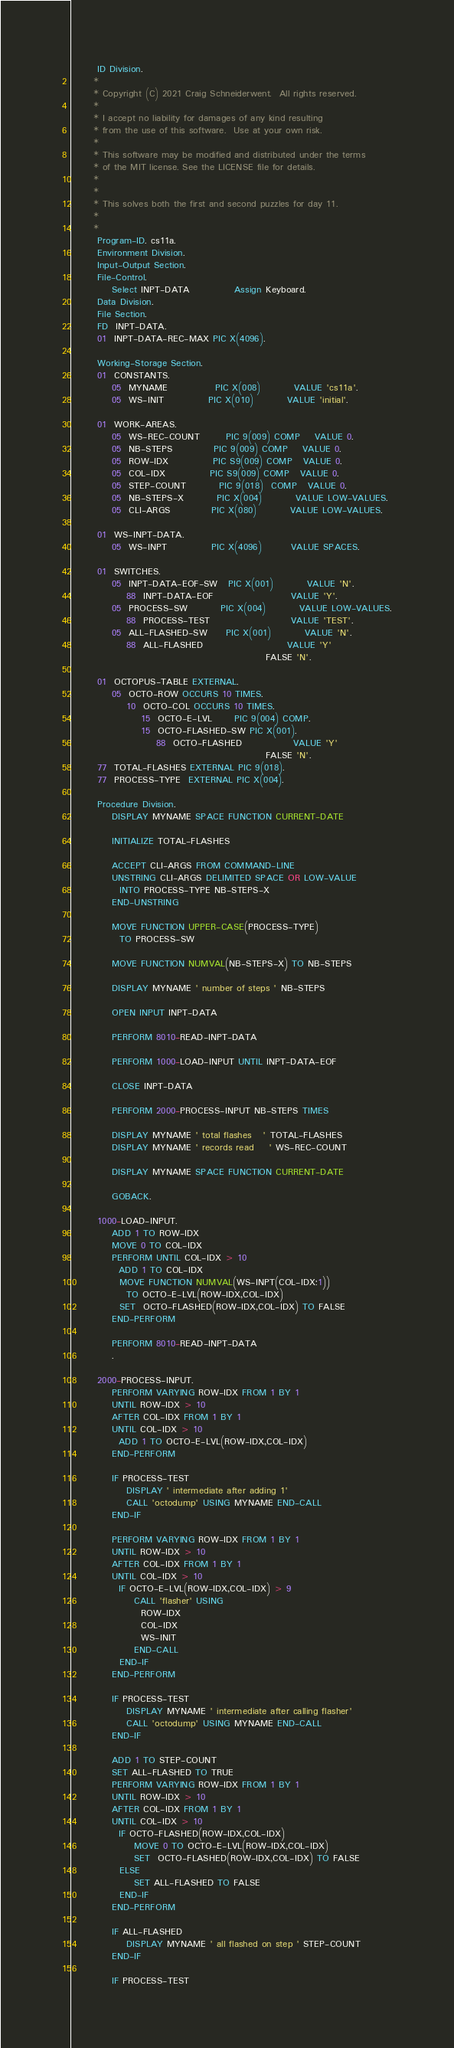<code> <loc_0><loc_0><loc_500><loc_500><_COBOL_>       ID Division.
      * 
      * Copyright (C) 2021 Craig Schneiderwent.  All rights reserved.
      * 
      * I accept no liability for damages of any kind resulting 
      * from the use of this software.  Use at your own risk.
      *
      * This software may be modified and distributed under the terms
      * of the MIT license. See the LICENSE file for details.
      *
      * 
      * This solves both the first and second puzzles for day 11. 
      * 
      * 
       Program-ID. cs11a.
       Environment Division.
       Input-Output Section.
       File-Control.
           Select INPT-DATA            Assign Keyboard.
       Data Division.
       File Section.
       FD  INPT-DATA.
       01  INPT-DATA-REC-MAX PIC X(4096).

       Working-Storage Section.
       01  CONSTANTS.
           05  MYNAME             PIC X(008)         VALUE 'cs11a'.
           05  WS-INIT            PIC X(010)         VALUE 'initial'.

       01  WORK-AREAS.
           05  WS-REC-COUNT       PIC 9(009) COMP    VALUE 0.
           05  NB-STEPS           PIC 9(009) COMP    VALUE 0.
           05  ROW-IDX            PIC S9(009) COMP   VALUE 0.
           05  COL-IDX            PIC S9(009) COMP   VALUE 0.
           05  STEP-COUNT         PIC 9(018)  COMP   VALUE 0.
           05  NB-STEPS-X         PIC X(004)         VALUE LOW-VALUES.
           05  CLI-ARGS           PIC X(080)         VALUE LOW-VALUES.

       01  WS-INPT-DATA.
           05  WS-INPT            PIC X(4096)        VALUE SPACES.

       01  SWITCHES.
           05  INPT-DATA-EOF-SW   PIC X(001)         VALUE 'N'.
               88  INPT-DATA-EOF                     VALUE 'Y'.
           05  PROCESS-SW         PIC X(004)         VALUE LOW-VALUES.
               88  PROCESS-TEST                      VALUE 'TEST'.
           05  ALL-FLASHED-SW     PIC X(001)         VALUE 'N'.
               88  ALL-FLASHED                       VALUE 'Y'
                                                     FALSE 'N'.

       01  OCTOPUS-TABLE EXTERNAL.
           05  OCTO-ROW OCCURS 10 TIMES.
               10  OCTO-COL OCCURS 10 TIMES.
                   15  OCTO-E-LVL      PIC 9(004) COMP.
                   15  OCTO-FLASHED-SW PIC X(001).
                       88  OCTO-FLASHED              VALUE 'Y'
                                                     FALSE 'N'.
       77  TOTAL-FLASHES EXTERNAL PIC 9(018).
       77  PROCESS-TYPE  EXTERNAL PIC X(004).

       Procedure Division.
           DISPLAY MYNAME SPACE FUNCTION CURRENT-DATE

           INITIALIZE TOTAL-FLASHES

           ACCEPT CLI-ARGS FROM COMMAND-LINE
           UNSTRING CLI-ARGS DELIMITED SPACE OR LOW-VALUE
             INTO PROCESS-TYPE NB-STEPS-X
           END-UNSTRING

           MOVE FUNCTION UPPER-CASE(PROCESS-TYPE)
             TO PROCESS-SW

           MOVE FUNCTION NUMVAL(NB-STEPS-X) TO NB-STEPS

           DISPLAY MYNAME ' number of steps ' NB-STEPS

           OPEN INPUT INPT-DATA

           PERFORM 8010-READ-INPT-DATA

           PERFORM 1000-LOAD-INPUT UNTIL INPT-DATA-EOF

           CLOSE INPT-DATA

           PERFORM 2000-PROCESS-INPUT NB-STEPS TIMES

           DISPLAY MYNAME ' total flashes   ' TOTAL-FLASHES
           DISPLAY MYNAME ' records read    ' WS-REC-COUNT

           DISPLAY MYNAME SPACE FUNCTION CURRENT-DATE

           GOBACK.

       1000-LOAD-INPUT.
           ADD 1 TO ROW-IDX
           MOVE 0 TO COL-IDX
           PERFORM UNTIL COL-IDX > 10
             ADD 1 TO COL-IDX
             MOVE FUNCTION NUMVAL(WS-INPT(COL-IDX:1))
               TO OCTO-E-LVL(ROW-IDX,COL-IDX)
             SET  OCTO-FLASHED(ROW-IDX,COL-IDX) TO FALSE
           END-PERFORM

           PERFORM 8010-READ-INPT-DATA
           .

       2000-PROCESS-INPUT.
           PERFORM VARYING ROW-IDX FROM 1 BY 1
           UNTIL ROW-IDX > 10
           AFTER COL-IDX FROM 1 BY 1
           UNTIL COL-IDX > 10
             ADD 1 TO OCTO-E-LVL(ROW-IDX,COL-IDX)
           END-PERFORM

           IF PROCESS-TEST
               DISPLAY ' intermediate after adding 1'
               CALL 'octodump' USING MYNAME END-CALL
           END-IF

           PERFORM VARYING ROW-IDX FROM 1 BY 1
           UNTIL ROW-IDX > 10
           AFTER COL-IDX FROM 1 BY 1
           UNTIL COL-IDX > 10
             IF OCTO-E-LVL(ROW-IDX,COL-IDX) > 9
                 CALL 'flasher' USING
                   ROW-IDX
                   COL-IDX
                   WS-INIT
                 END-CALL
             END-IF
           END-PERFORM

           IF PROCESS-TEST
               DISPLAY MYNAME ' intermediate after calling flasher'
               CALL 'octodump' USING MYNAME END-CALL
           END-IF

           ADD 1 TO STEP-COUNT
           SET ALL-FLASHED TO TRUE
           PERFORM VARYING ROW-IDX FROM 1 BY 1
           UNTIL ROW-IDX > 10
           AFTER COL-IDX FROM 1 BY 1
           UNTIL COL-IDX > 10
             IF OCTO-FLASHED(ROW-IDX,COL-IDX)
                 MOVE 0 TO OCTO-E-LVL(ROW-IDX,COL-IDX)
                 SET  OCTO-FLASHED(ROW-IDX,COL-IDX) TO FALSE
             ELSE
                 SET ALL-FLASHED TO FALSE
             END-IF
           END-PERFORM

           IF ALL-FLASHED
               DISPLAY MYNAME ' all flashed on step ' STEP-COUNT
           END-IF

           IF PROCESS-TEST</code> 